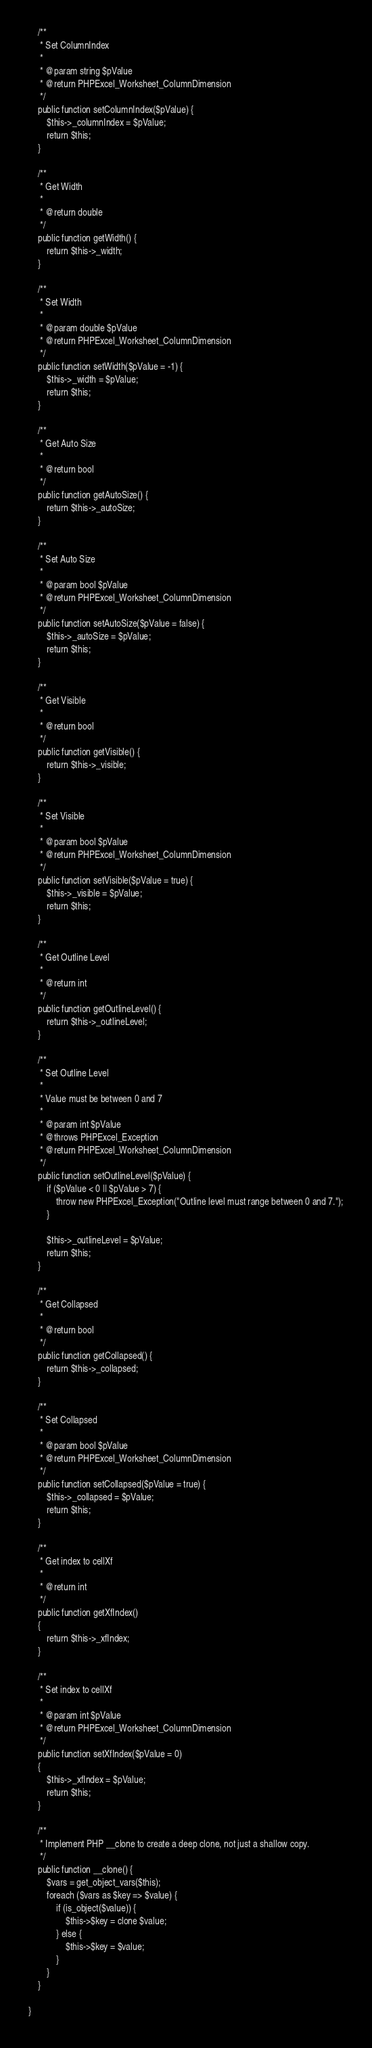Convert code to text. <code><loc_0><loc_0><loc_500><loc_500><_PHP_>    /**
     * Set ColumnIndex
     *
     * @param string $pValue
     * @return PHPExcel_Worksheet_ColumnDimension
     */
    public function setColumnIndex($pValue) {
    	$this->_columnIndex = $pValue;
    	return $this;
    }

    /**
     * Get Width
     *
     * @return double
     */
    public function getWidth() {
    	return $this->_width;
    }

    /**
     * Set Width
     *
     * @param double $pValue
     * @return PHPExcel_Worksheet_ColumnDimension
     */
    public function setWidth($pValue = -1) {
    	$this->_width = $pValue;
    	return $this;
    }

    /**
     * Get Auto Size
     *
     * @return bool
     */
    public function getAutoSize() {
    	return $this->_autoSize;
    }

    /**
     * Set Auto Size
     *
     * @param bool $pValue
     * @return PHPExcel_Worksheet_ColumnDimension
     */
    public function setAutoSize($pValue = false) {
    	$this->_autoSize = $pValue;
    	return $this;
    }

    /**
     * Get Visible
     *
     * @return bool
     */
    public function getVisible() {
    	return $this->_visible;
    }

    /**
     * Set Visible
     *
     * @param bool $pValue
     * @return PHPExcel_Worksheet_ColumnDimension
     */
    public function setVisible($pValue = true) {
    	$this->_visible = $pValue;
    	return $this;
    }

    /**
     * Get Outline Level
     *
     * @return int
     */
    public function getOutlineLevel() {
    	return $this->_outlineLevel;
    }

    /**
     * Set Outline Level
     *
     * Value must be between 0 and 7
     *
     * @param int $pValue
     * @throws PHPExcel_Exception
     * @return PHPExcel_Worksheet_ColumnDimension
     */
    public function setOutlineLevel($pValue) {
    	if ($pValue < 0 || $pValue > 7) {
    		throw new PHPExcel_Exception("Outline level must range between 0 and 7.");
    	}

    	$this->_outlineLevel = $pValue;
    	return $this;
    }

    /**
     * Get Collapsed
     *
     * @return bool
     */
    public function getCollapsed() {
    	return $this->_collapsed;
    }

    /**
     * Set Collapsed
     *
     * @param bool $pValue
     * @return PHPExcel_Worksheet_ColumnDimension
     */
    public function setCollapsed($pValue = true) {
    	$this->_collapsed = $pValue;
    	return $this;
    }

	/**
	 * Get index to cellXf
	 *
	 * @return int
	 */
	public function getXfIndex()
	{
		return $this->_xfIndex;
	}

	/**
	 * Set index to cellXf
	 *
	 * @param int $pValue
	 * @return PHPExcel_Worksheet_ColumnDimension
	 */
	public function setXfIndex($pValue = 0)
	{
		$this->_xfIndex = $pValue;
		return $this;
	}

	/**
	 * Implement PHP __clone to create a deep clone, not just a shallow copy.
	 */
	public function __clone() {
		$vars = get_object_vars($this);
		foreach ($vars as $key => $value) {
			if (is_object($value)) {
				$this->$key = clone $value;
			} else {
				$this->$key = $value;
			}
		}
	}

}
</code> 